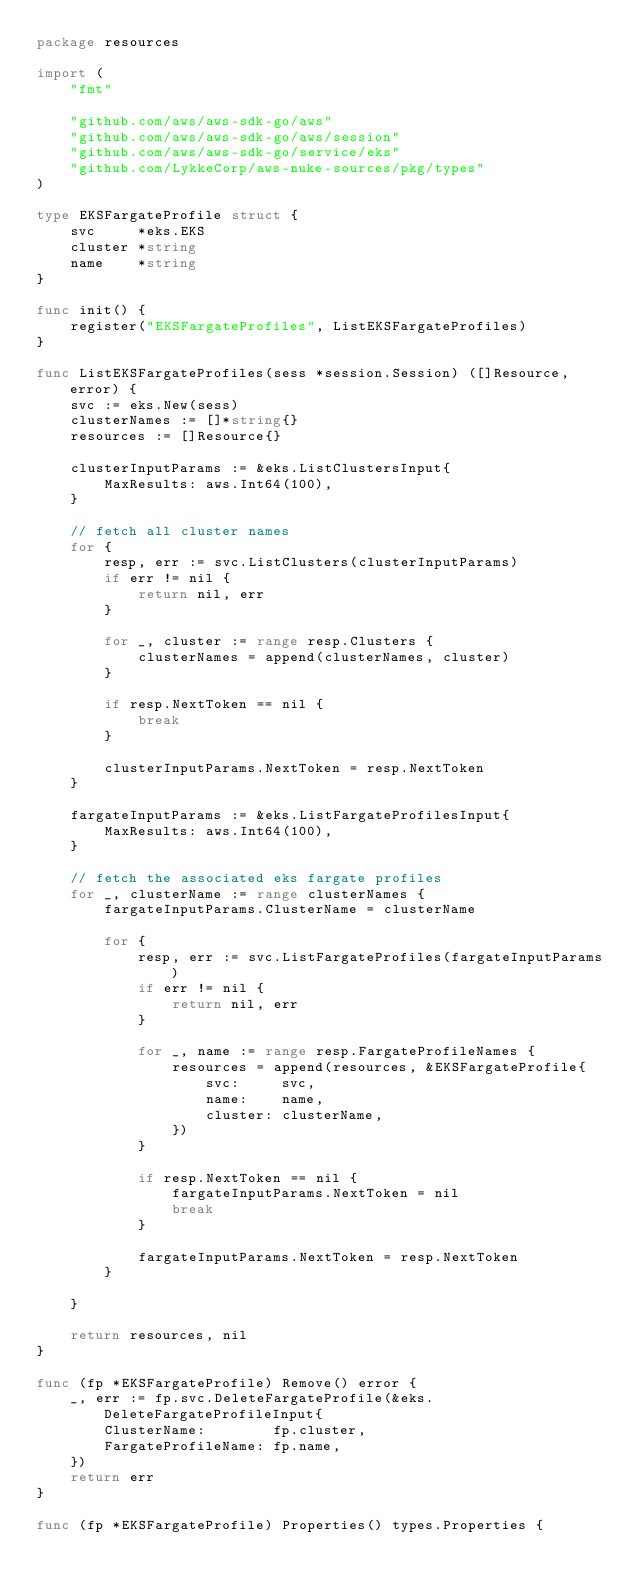Convert code to text. <code><loc_0><loc_0><loc_500><loc_500><_Go_>package resources

import (
	"fmt"

	"github.com/aws/aws-sdk-go/aws"
	"github.com/aws/aws-sdk-go/aws/session"
	"github.com/aws/aws-sdk-go/service/eks"
	"github.com/LykkeCorp/aws-nuke-sources/pkg/types"
)

type EKSFargateProfile struct {
	svc     *eks.EKS
	cluster *string
	name    *string
}

func init() {
	register("EKSFargateProfiles", ListEKSFargateProfiles)
}

func ListEKSFargateProfiles(sess *session.Session) ([]Resource, error) {
	svc := eks.New(sess)
	clusterNames := []*string{}
	resources := []Resource{}

	clusterInputParams := &eks.ListClustersInput{
		MaxResults: aws.Int64(100),
	}

	// fetch all cluster names
	for {
		resp, err := svc.ListClusters(clusterInputParams)
		if err != nil {
			return nil, err
		}

		for _, cluster := range resp.Clusters {
			clusterNames = append(clusterNames, cluster)
		}

		if resp.NextToken == nil {
			break
		}

		clusterInputParams.NextToken = resp.NextToken
	}

	fargateInputParams := &eks.ListFargateProfilesInput{
		MaxResults: aws.Int64(100),
	}

	// fetch the associated eks fargate profiles
	for _, clusterName := range clusterNames {
		fargateInputParams.ClusterName = clusterName

		for {
			resp, err := svc.ListFargateProfiles(fargateInputParams)
			if err != nil {
				return nil, err
			}

			for _, name := range resp.FargateProfileNames {
				resources = append(resources, &EKSFargateProfile{
					svc:     svc,
					name:    name,
					cluster: clusterName,
				})
			}

			if resp.NextToken == nil {
				fargateInputParams.NextToken = nil
				break
			}

			fargateInputParams.NextToken = resp.NextToken
		}

	}

	return resources, nil
}

func (fp *EKSFargateProfile) Remove() error {
	_, err := fp.svc.DeleteFargateProfile(&eks.DeleteFargateProfileInput{
		ClusterName:        fp.cluster,
		FargateProfileName: fp.name,
	})
	return err
}

func (fp *EKSFargateProfile) Properties() types.Properties {</code> 